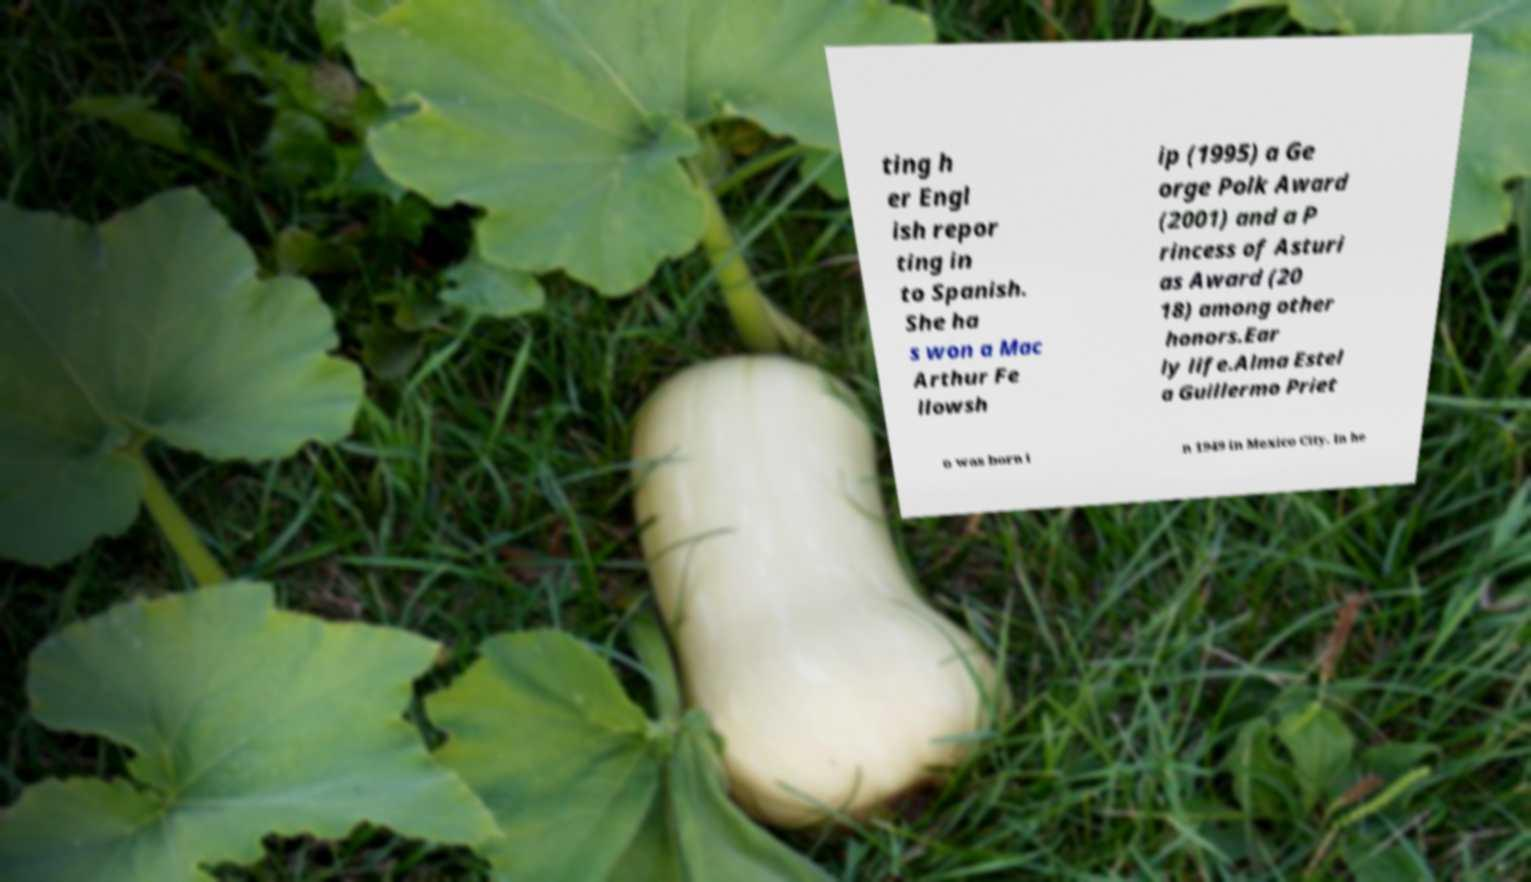Can you read and provide the text displayed in the image?This photo seems to have some interesting text. Can you extract and type it out for me? ting h er Engl ish repor ting in to Spanish. She ha s won a Mac Arthur Fe llowsh ip (1995) a Ge orge Polk Award (2001) and a P rincess of Asturi as Award (20 18) among other honors.Ear ly life.Alma Estel a Guillermo Priet o was born i n 1949 in Mexico City. In he 